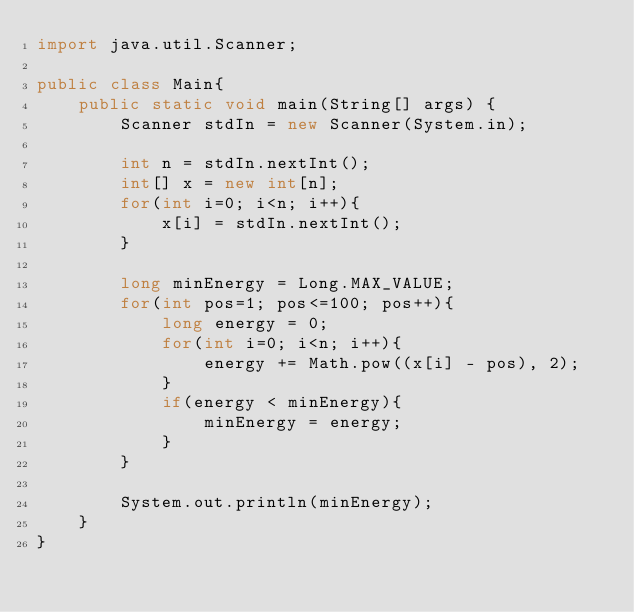<code> <loc_0><loc_0><loc_500><loc_500><_Java_>import java.util.Scanner;

public class Main{
    public static void main(String[] args) {
        Scanner stdIn = new Scanner(System.in);

        int n = stdIn.nextInt();
        int[] x = new int[n];
        for(int i=0; i<n; i++){
            x[i] = stdIn.nextInt();
        }

        long minEnergy = Long.MAX_VALUE;
        for(int pos=1; pos<=100; pos++){
            long energy = 0;
            for(int i=0; i<n; i++){
                energy += Math.pow((x[i] - pos), 2);
            }
            if(energy < minEnergy){
                minEnergy = energy;
            }
        }

        System.out.println(minEnergy);
    }
}</code> 